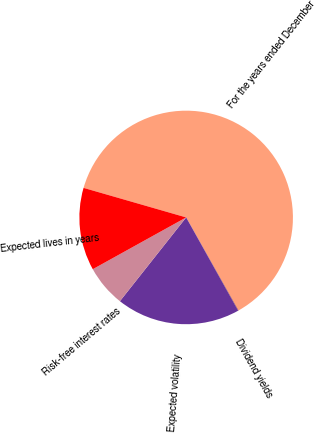Convert chart. <chart><loc_0><loc_0><loc_500><loc_500><pie_chart><fcel>For the years ended December<fcel>Dividend yields<fcel>Expected volatility<fcel>Risk-free interest rates<fcel>Expected lives in years<nl><fcel>62.37%<fcel>0.06%<fcel>18.75%<fcel>6.29%<fcel>12.52%<nl></chart> 